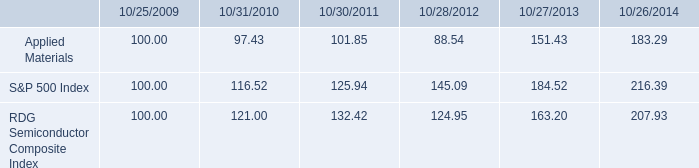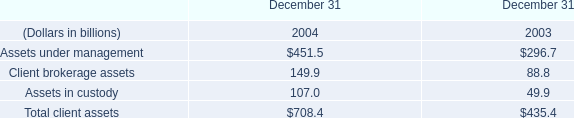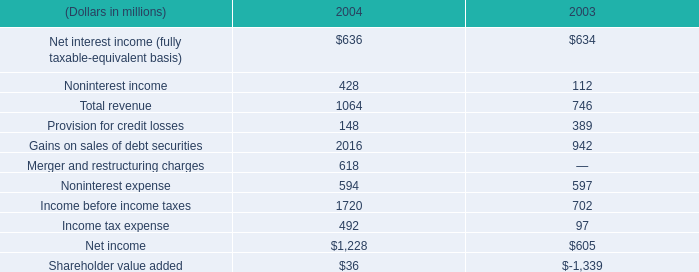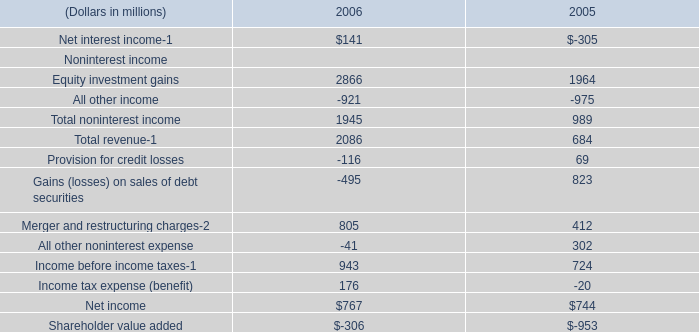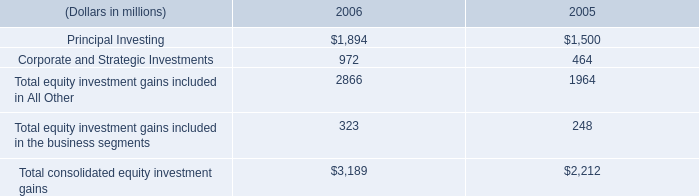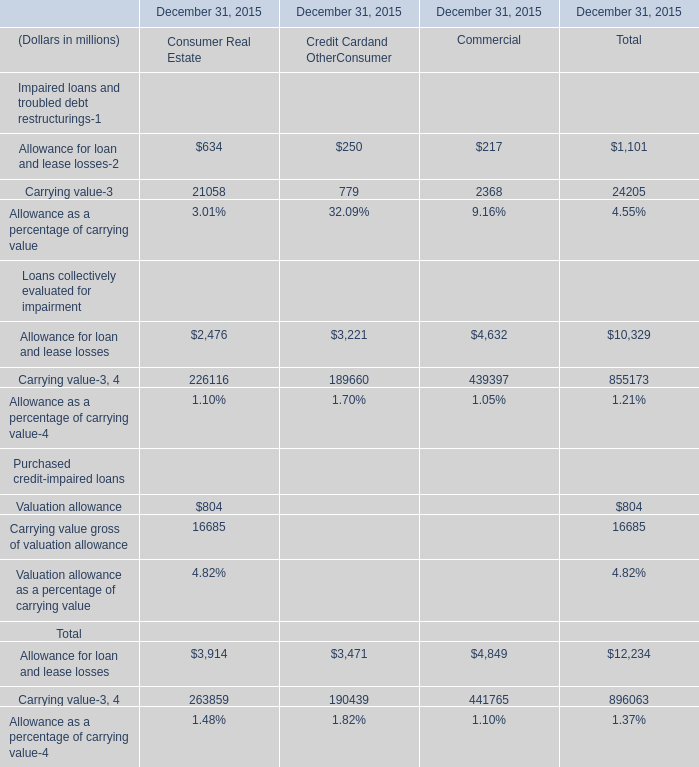what is the return on investment for applied materials if the investment occurred in 2009 and it is liquidated in 2012? 
Computations: ((88.54 - 100) / 100)
Answer: -0.1146. 